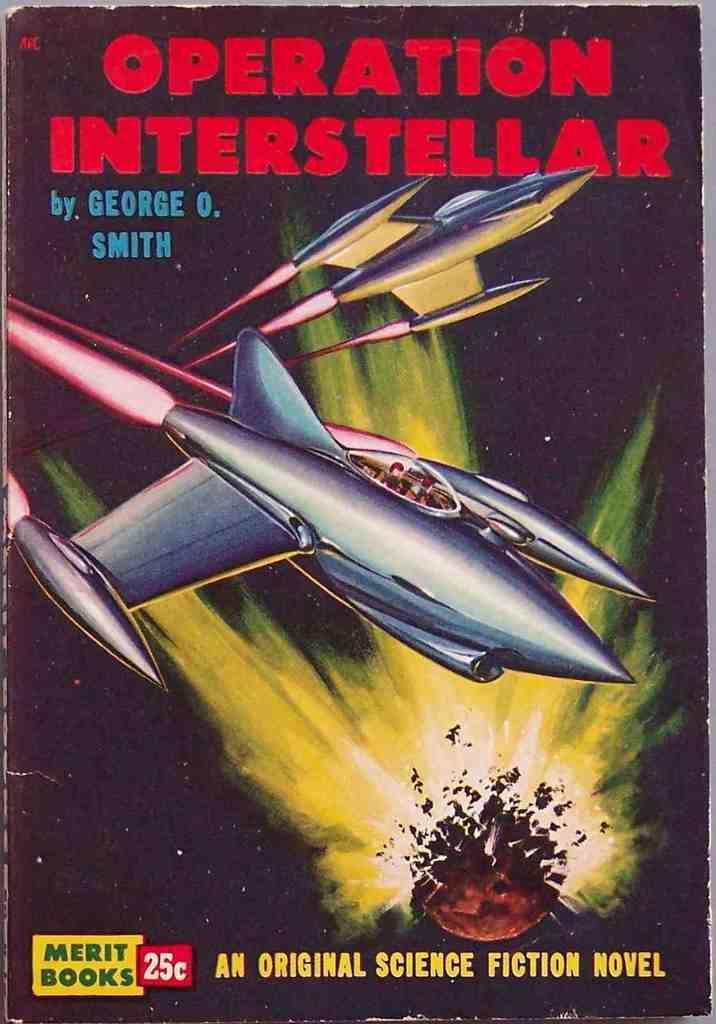Please provide a concise description of this image. In this image we can see a book and it looks like a book cover page and we can see some text and the picture of two aircrafts. 